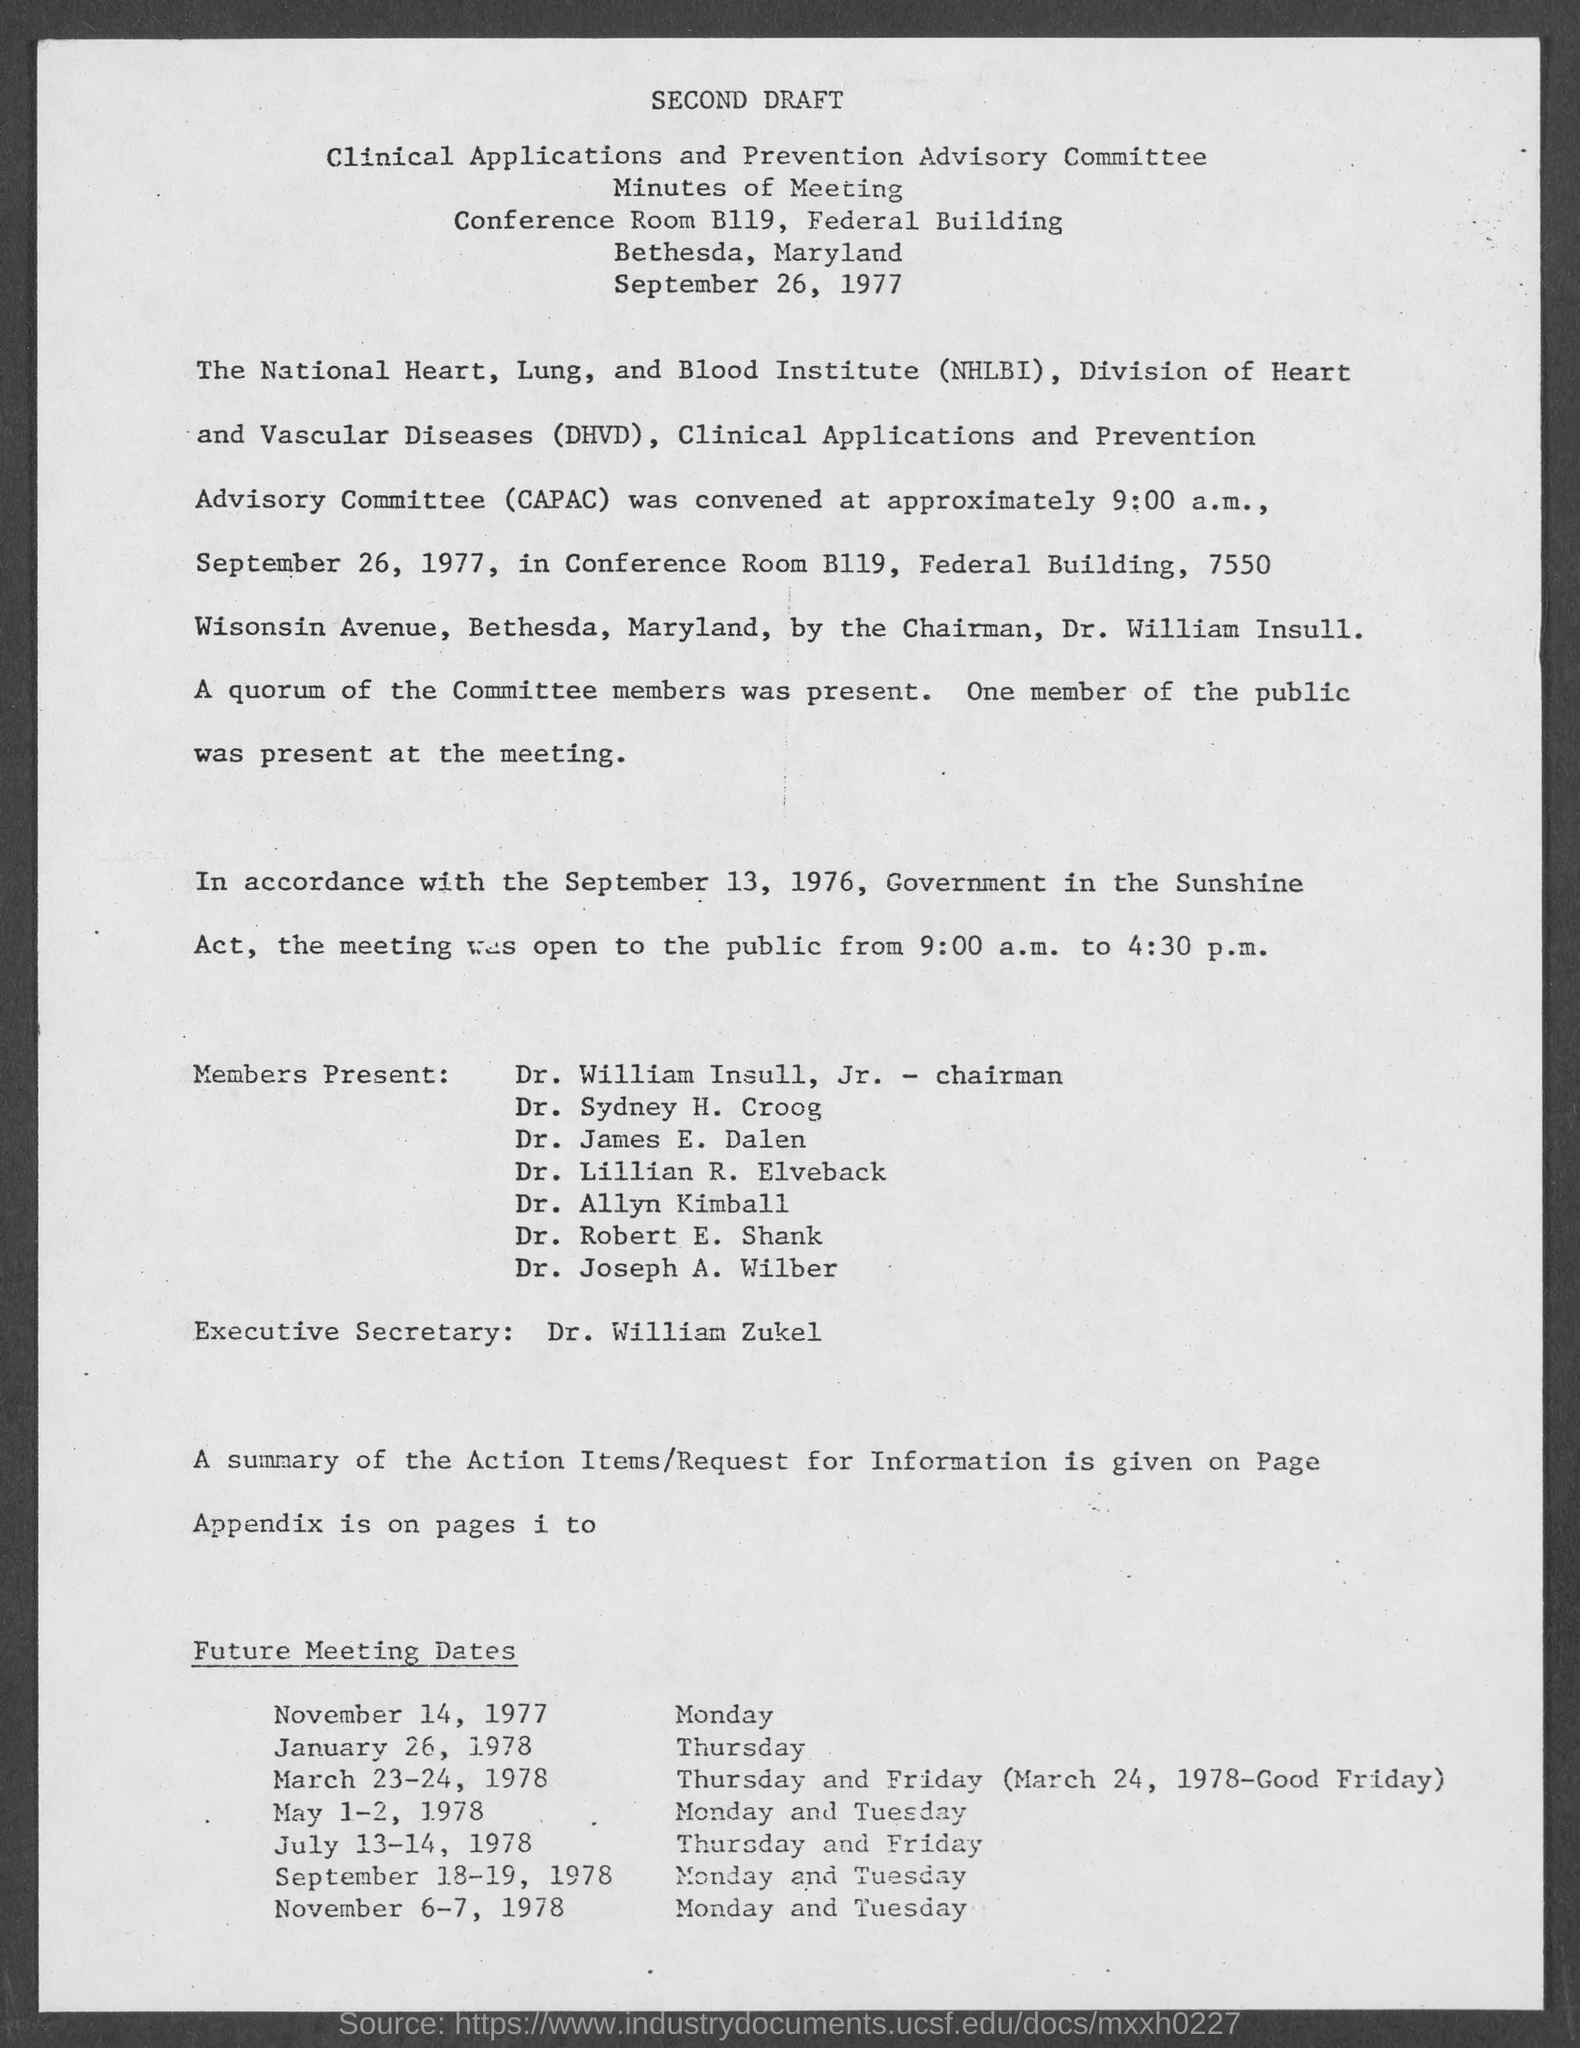Draw attention to some important aspects in this diagram. The title of the document is Second Draft. 